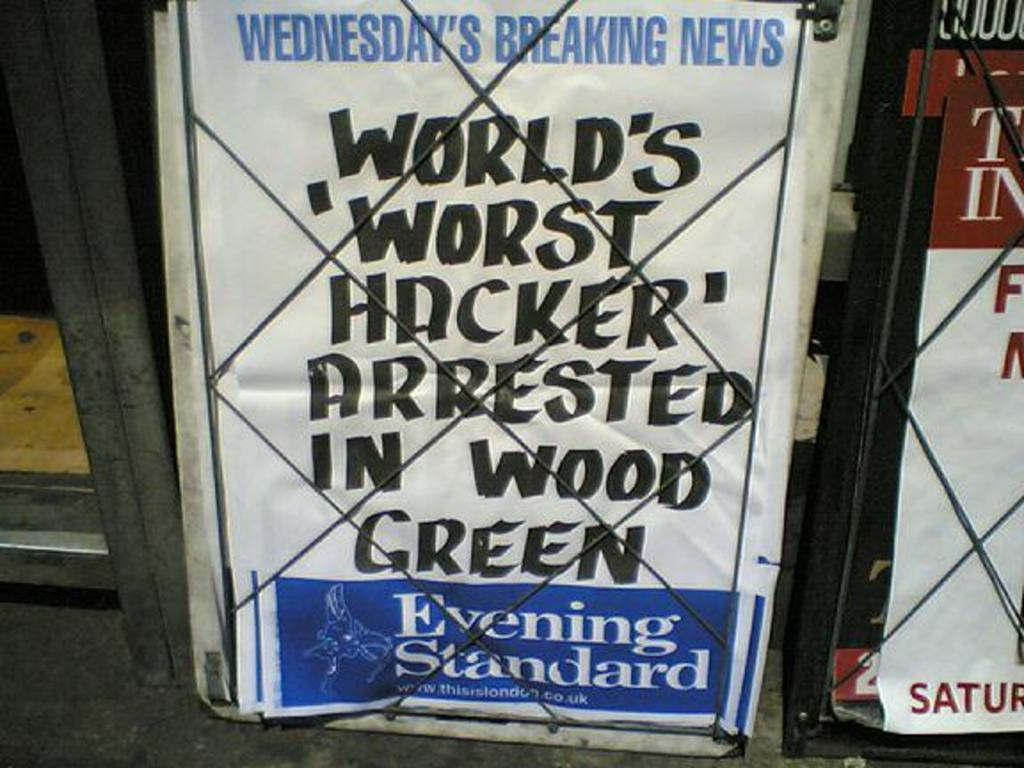Provide a one-sentence caption for the provided image. Sign behind a fence that is about Wednesday's Breaking News. 